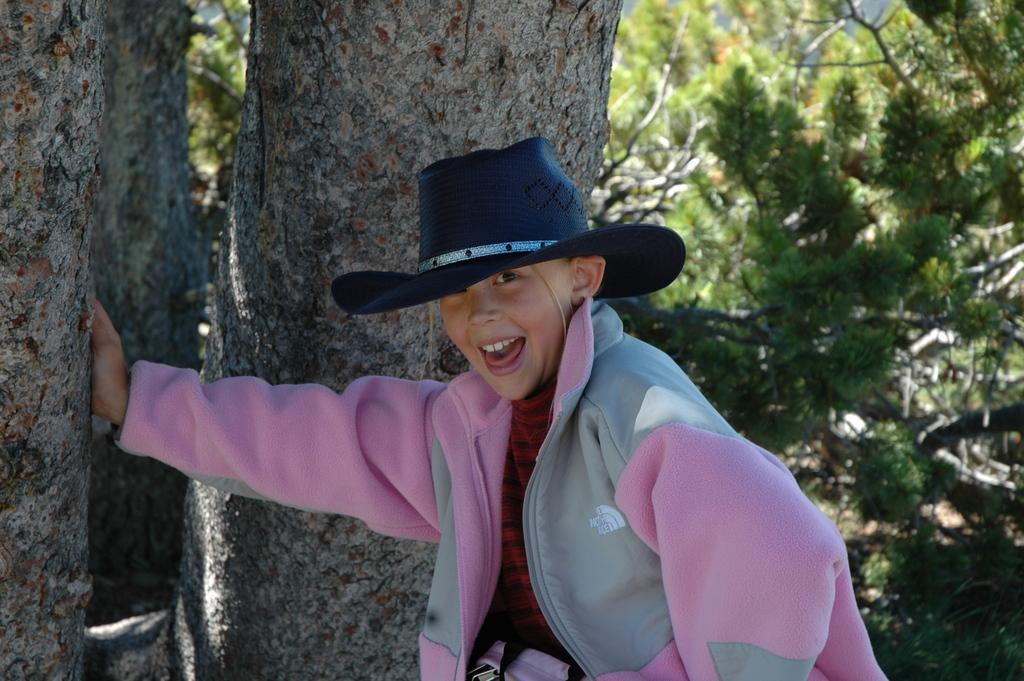Could you give a brief overview of what you see in this image? In this image there is a kid wearing a jacket and a hat. He is keeping the hand on the tree trunk. Background there are trees. 